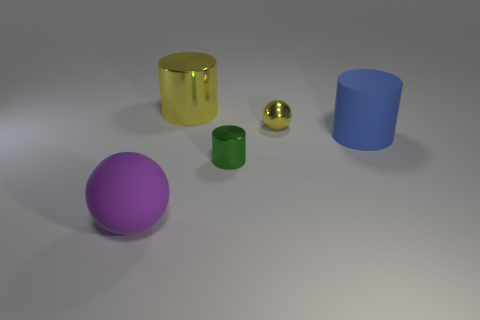Does the large blue object have the same shape as the small shiny thing in front of the large blue object?
Your answer should be compact. Yes. Are there fewer blue objects that are to the right of the blue matte cylinder than metal objects that are behind the small shiny cylinder?
Give a very brief answer. Yes. Are there any other things that have the same shape as the small green metallic thing?
Your response must be concise. Yes. Is the shape of the purple thing the same as the blue object?
Give a very brief answer. No. Is there any other thing that is the same material as the small green cylinder?
Offer a very short reply. Yes. How big is the purple matte sphere?
Offer a terse response. Large. The thing that is both in front of the big rubber cylinder and on the right side of the large purple sphere is what color?
Give a very brief answer. Green. Is the number of tiny red rubber spheres greater than the number of large blue things?
Keep it short and to the point. No. How many objects are big objects or large things that are behind the purple matte thing?
Provide a succinct answer. 3. Is the purple matte thing the same size as the green cylinder?
Offer a terse response. No. 